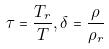<formula> <loc_0><loc_0><loc_500><loc_500>\tau = \frac { T _ { r } } { T } , \delta = \frac { \rho } { \rho _ { r } }</formula> 